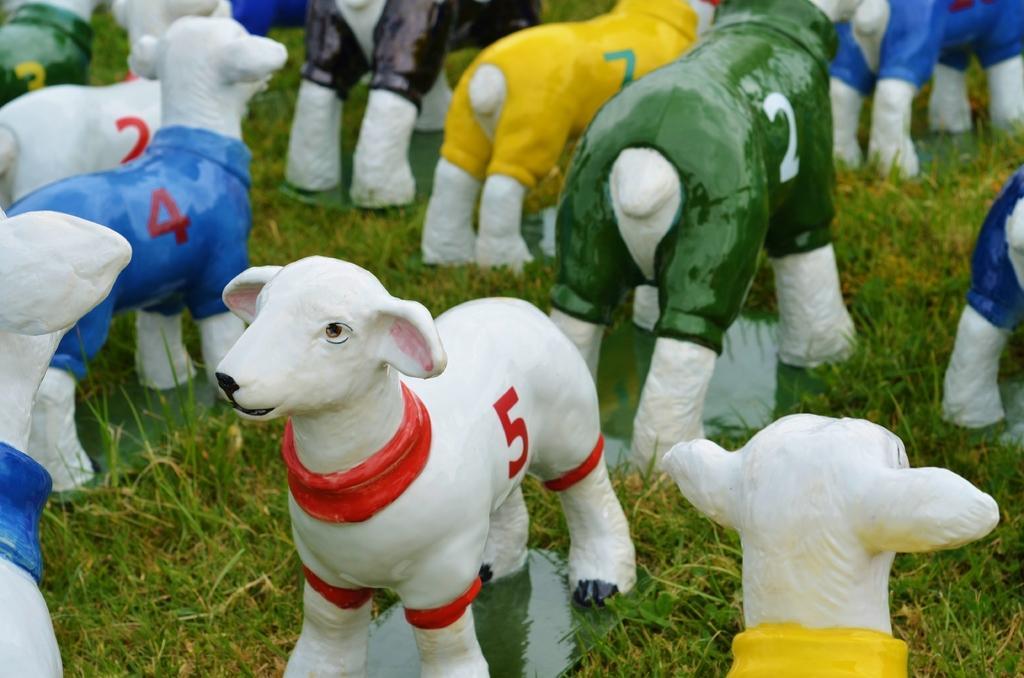Please provide a concise description of this image. In the center of the image we can see a few sheep statues with some dresses and numbers on it. And we can see the grass. 